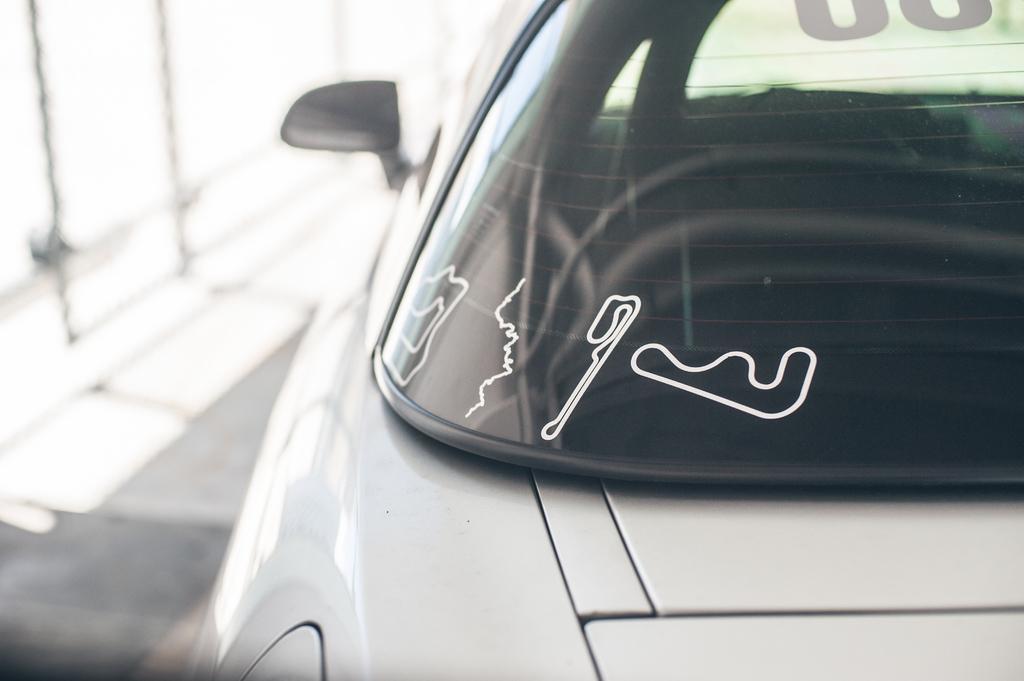Could you give a brief overview of what you see in this image? In this image I can see a white colour vehicle. I can also see few white stickers on its windshield and I can see this image is little bit blurry in the background. 